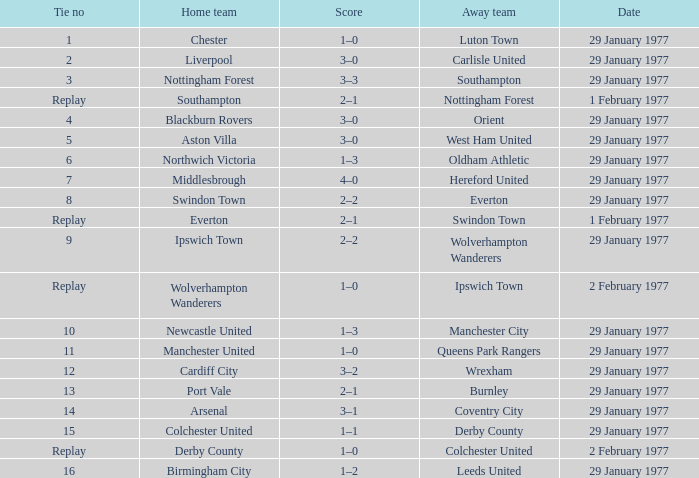What is the score in the Liverpool home game? 3–0. Can you give me this table as a dict? {'header': ['Tie no', 'Home team', 'Score', 'Away team', 'Date'], 'rows': [['1', 'Chester', '1–0', 'Luton Town', '29 January 1977'], ['2', 'Liverpool', '3–0', 'Carlisle United', '29 January 1977'], ['3', 'Nottingham Forest', '3–3', 'Southampton', '29 January 1977'], ['Replay', 'Southampton', '2–1', 'Nottingham Forest', '1 February 1977'], ['4', 'Blackburn Rovers', '3–0', 'Orient', '29 January 1977'], ['5', 'Aston Villa', '3–0', 'West Ham United', '29 January 1977'], ['6', 'Northwich Victoria', '1–3', 'Oldham Athletic', '29 January 1977'], ['7', 'Middlesbrough', '4–0', 'Hereford United', '29 January 1977'], ['8', 'Swindon Town', '2–2', 'Everton', '29 January 1977'], ['Replay', 'Everton', '2–1', 'Swindon Town', '1 February 1977'], ['9', 'Ipswich Town', '2–2', 'Wolverhampton Wanderers', '29 January 1977'], ['Replay', 'Wolverhampton Wanderers', '1–0', 'Ipswich Town', '2 February 1977'], ['10', 'Newcastle United', '1–3', 'Manchester City', '29 January 1977'], ['11', 'Manchester United', '1–0', 'Queens Park Rangers', '29 January 1977'], ['12', 'Cardiff City', '3–2', 'Wrexham', '29 January 1977'], ['13', 'Port Vale', '2–1', 'Burnley', '29 January 1977'], ['14', 'Arsenal', '3–1', 'Coventry City', '29 January 1977'], ['15', 'Colchester United', '1–1', 'Derby County', '29 January 1977'], ['Replay', 'Derby County', '1–0', 'Colchester United', '2 February 1977'], ['16', 'Birmingham City', '1–2', 'Leeds United', '29 January 1977']]} 